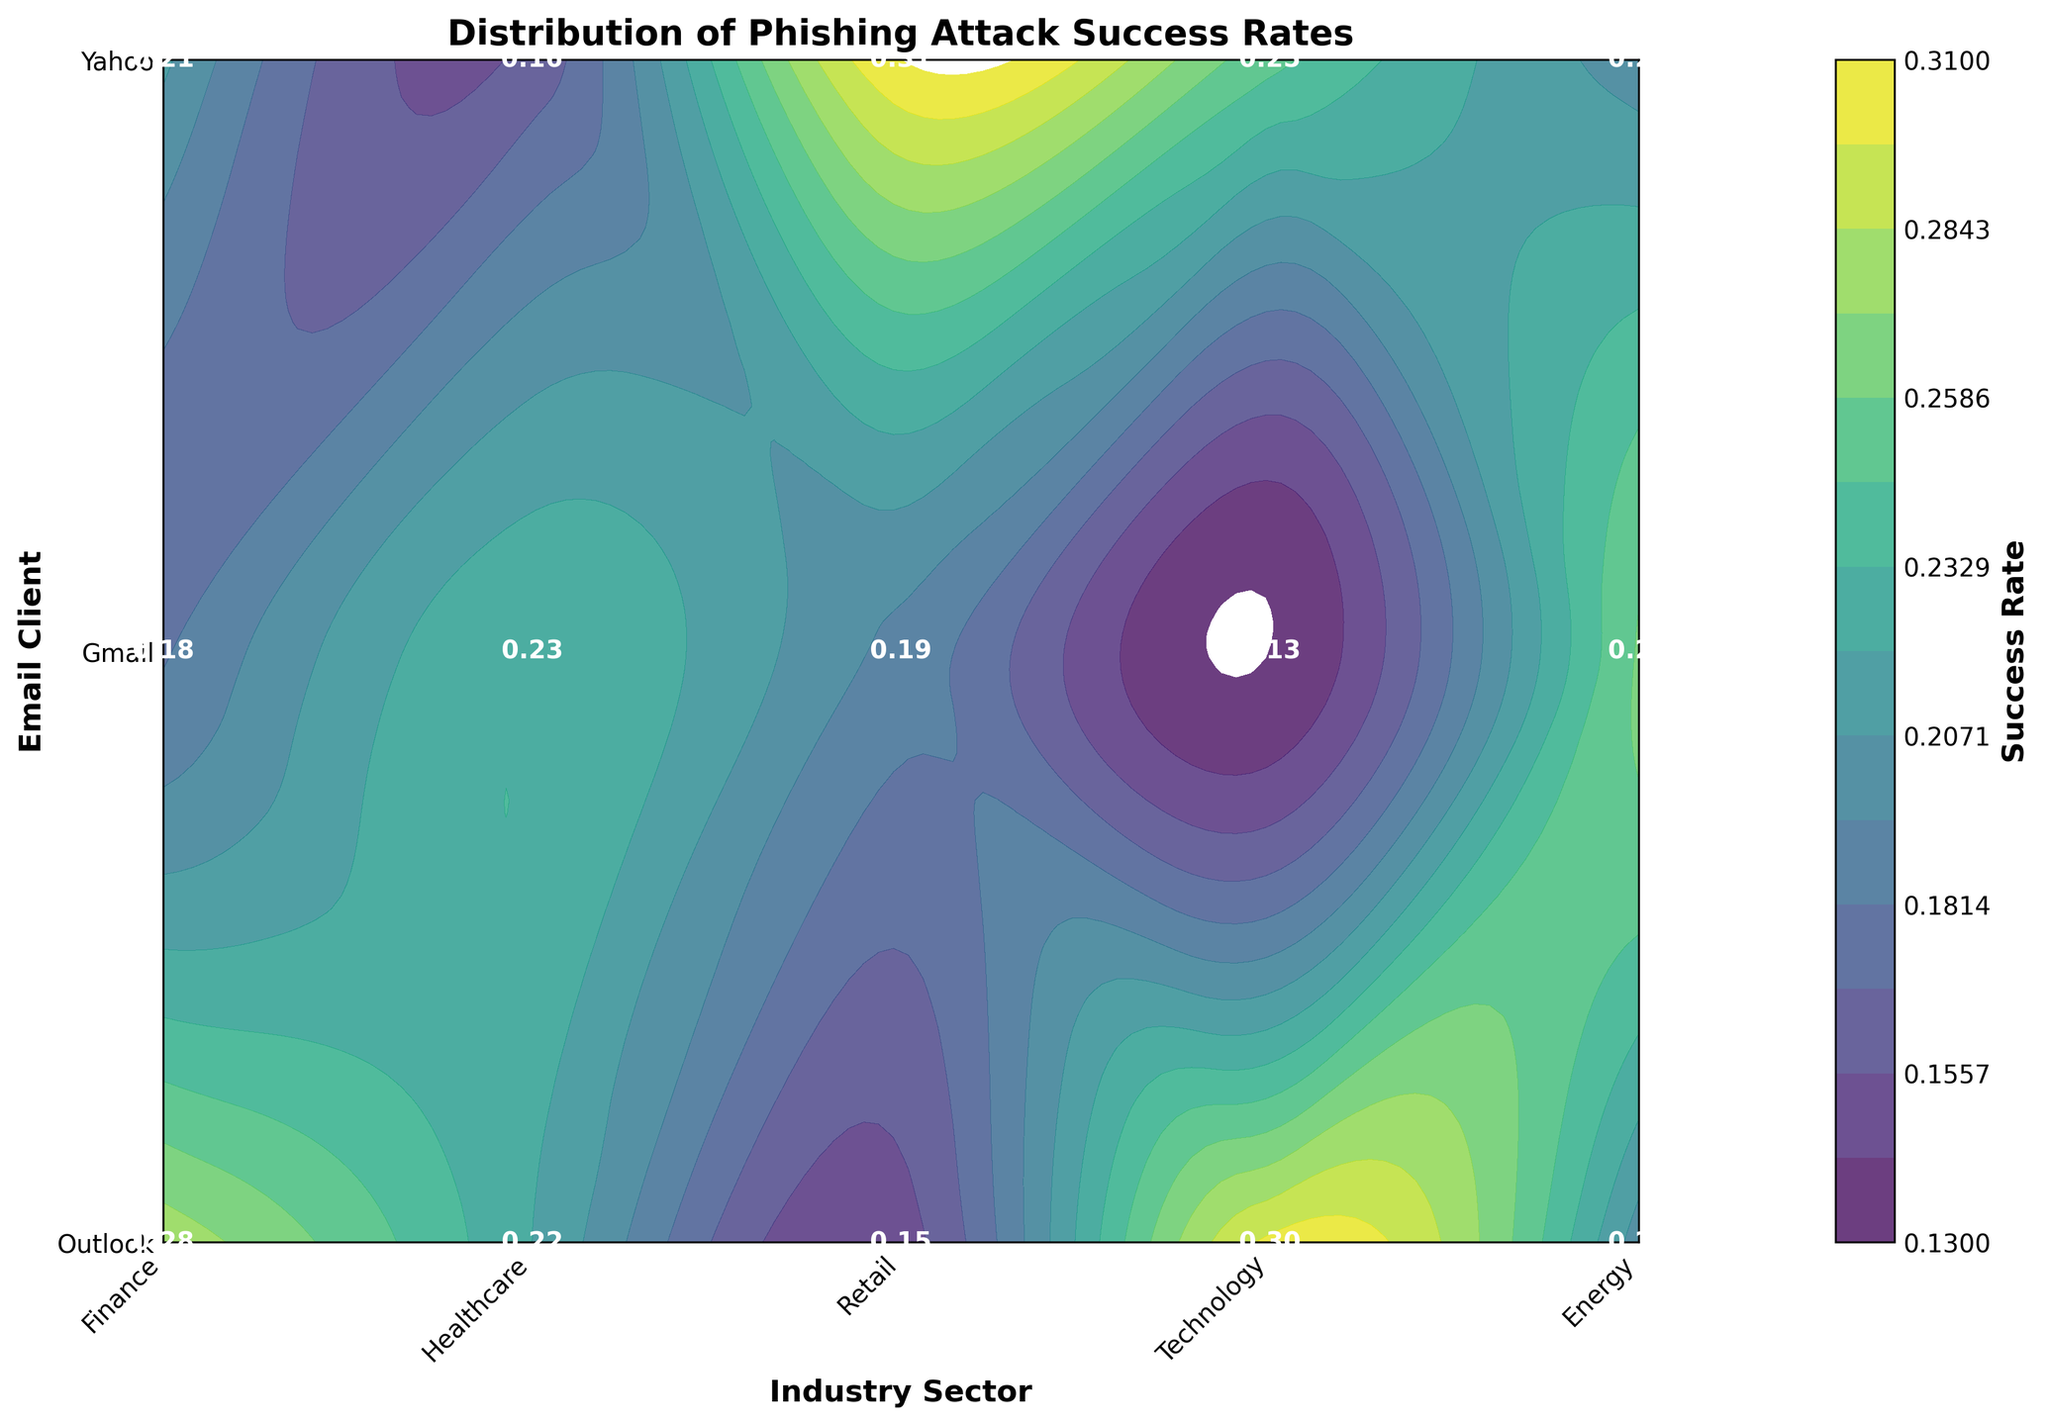What is the title of the figure? The title is usually positioned at the top of the figure in a larger font.
Answer: Distribution of Phishing Attack Success Rates Which industry sector has the highest phishing attack success rate for Outlook? By looking at the contour plot or the annotated success rates within the plot for the Outlook email client, we find the highest value.
Answer: Energy What is the success rate for Gmail in the Healthcare sector? Locate the Healthcare sector on the x-axis and Gmail on the y-axis, then find the success rate at their intersection.
Answer: 0.20 Compare the success rates of Outlook and Yahoo within the Retail sector. Which is higher? Find the annotated success rates for both Outlook and Yahoo within the Retail sector and compare their values.
Answer: Outlook What is the difference in success rates between the Finance and Technology sectors for Yahoo? Locate the success rates for Yahoo in both Finance and Technology sectors, then subtract the smaller value from the larger one. The relevant values are 0.15 (Finance) and 0.16 (Technology). So, the difference is 0.16 - 0.15 = 0.01.
Answer: 0.01 Which email client has the lowest overall phishing attack success rate across all industry sectors? Identify the lowest value in the entire contour plot or among the annotated success rates. This occurs in the Retail sector for Yahoo which has the lowest value at 0.13.
Answer: Yahoo What is the average phishing attack success rate for the Gmail email client across all industry sectors? Sum the success rates for Gmail across all sectors and then divide by the number of sectors (5). The values are 0.22, 0.20, 0.19, 0.21, and 0.25. The sum is 1.07. The average is 1.07/5 = 0.214.
Answer: 0.214 In which industry sector is the phishing attack success rate for Yahoo closest to the average success rate for Yahoo across all sectors? First, calculate the average success rate for Yahoo: (0.15 + 0.18 + 0.13 + 0.16 + 0.20) / 5 = 0.164. Then, compare the individual sector rates for Yahoo with the average and find the closest value.
Answer: Technology How does the success rate for Outlook in Healthcare compare to the success rate for Outlook in the Energy sector? Compare the annotated success rates for Outlook within these two sectors (0.30 for Healthcare and 0.31 for Energy).
Answer: Energy is slightly higher Which industry sector shows the least variation in success rates across different email clients? For each sector, determine the range (maximum - minimum) of success rates across different email clients. The sector with the smallest range indicates the least variation. Calculation steps:
- Finance: max(0.28, 0.22, 0.15) - min(0.28, 0.22, 0.15) = 0.28 - 0.15 = 0.13
- Healthcare: max(0.30, 0.20, 0.18) - min(0.30, 0.20, 0.18) = 0.30 - 0.18 = 0.12
- Retail: max(0.23, 0.19, 0.13) - min(0.23, 0.19, 0.13) = 0.23 - 0.13 = 0.10
- Technology: max(0.26, 0.21, 0.16) - min(0.26, 0.21, 0.16) = 0.26 - 0.16 = 0.10
- Energy: max(0.31, 0.25, 0.20) - min(0.31, 0.25, 0.20) = 0.31 - 0.20 = 0.11
Retail and Technology both have the least variation.
Answer: Retail and Technology 